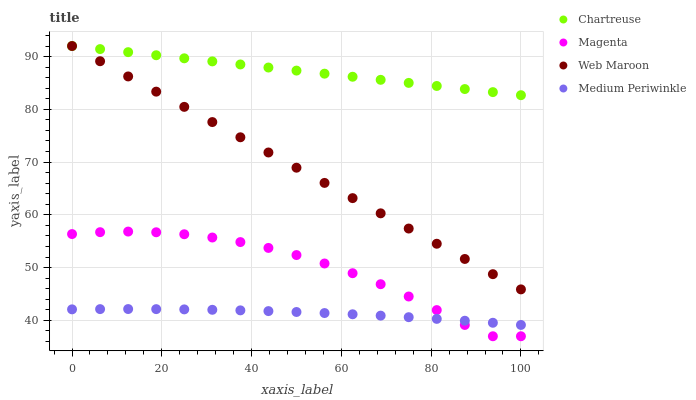Does Medium Periwinkle have the minimum area under the curve?
Answer yes or no. Yes. Does Chartreuse have the maximum area under the curve?
Answer yes or no. Yes. Does Web Maroon have the minimum area under the curve?
Answer yes or no. No. Does Web Maroon have the maximum area under the curve?
Answer yes or no. No. Is Chartreuse the smoothest?
Answer yes or no. Yes. Is Magenta the roughest?
Answer yes or no. Yes. Is Web Maroon the smoothest?
Answer yes or no. No. Is Web Maroon the roughest?
Answer yes or no. No. Does Magenta have the lowest value?
Answer yes or no. Yes. Does Web Maroon have the lowest value?
Answer yes or no. No. Does Web Maroon have the highest value?
Answer yes or no. Yes. Does Magenta have the highest value?
Answer yes or no. No. Is Medium Periwinkle less than Chartreuse?
Answer yes or no. Yes. Is Web Maroon greater than Magenta?
Answer yes or no. Yes. Does Magenta intersect Medium Periwinkle?
Answer yes or no. Yes. Is Magenta less than Medium Periwinkle?
Answer yes or no. No. Is Magenta greater than Medium Periwinkle?
Answer yes or no. No. Does Medium Periwinkle intersect Chartreuse?
Answer yes or no. No. 